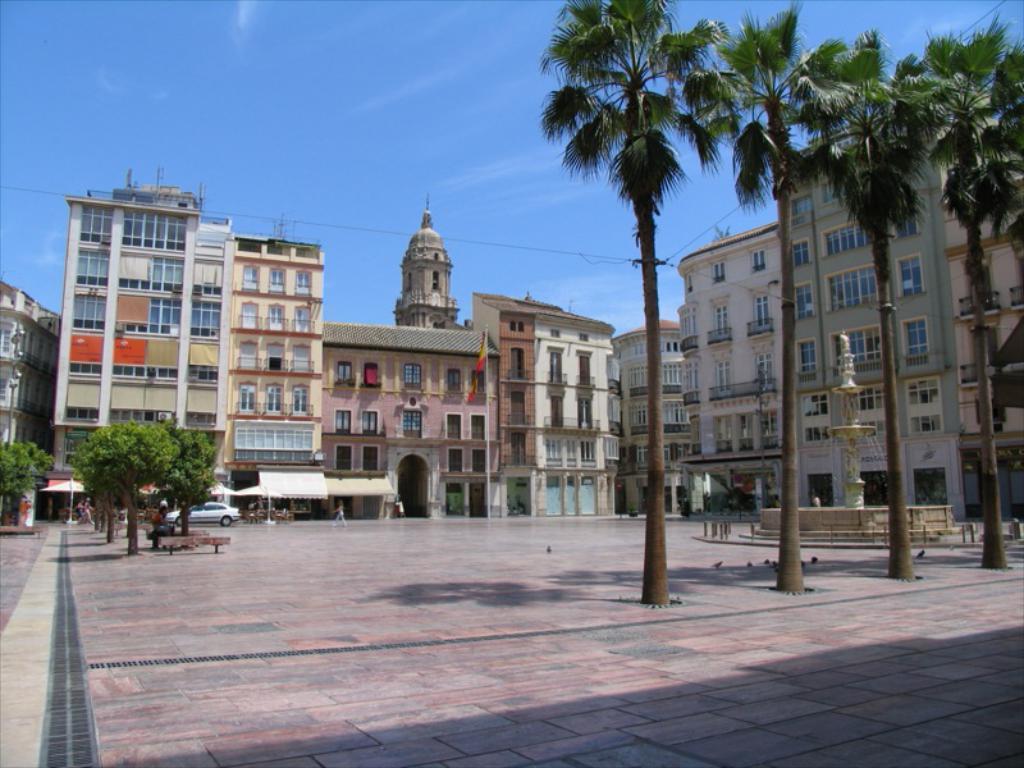Describe this image in one or two sentences. In this image, there are a few buildings. We can see some trees. There are a few people. We can see the ground with some objects. We can also see the waterfall. We can see an umbrella. We can see some poles. We can see a vehicle. We can see some wires. We can see the sky. 